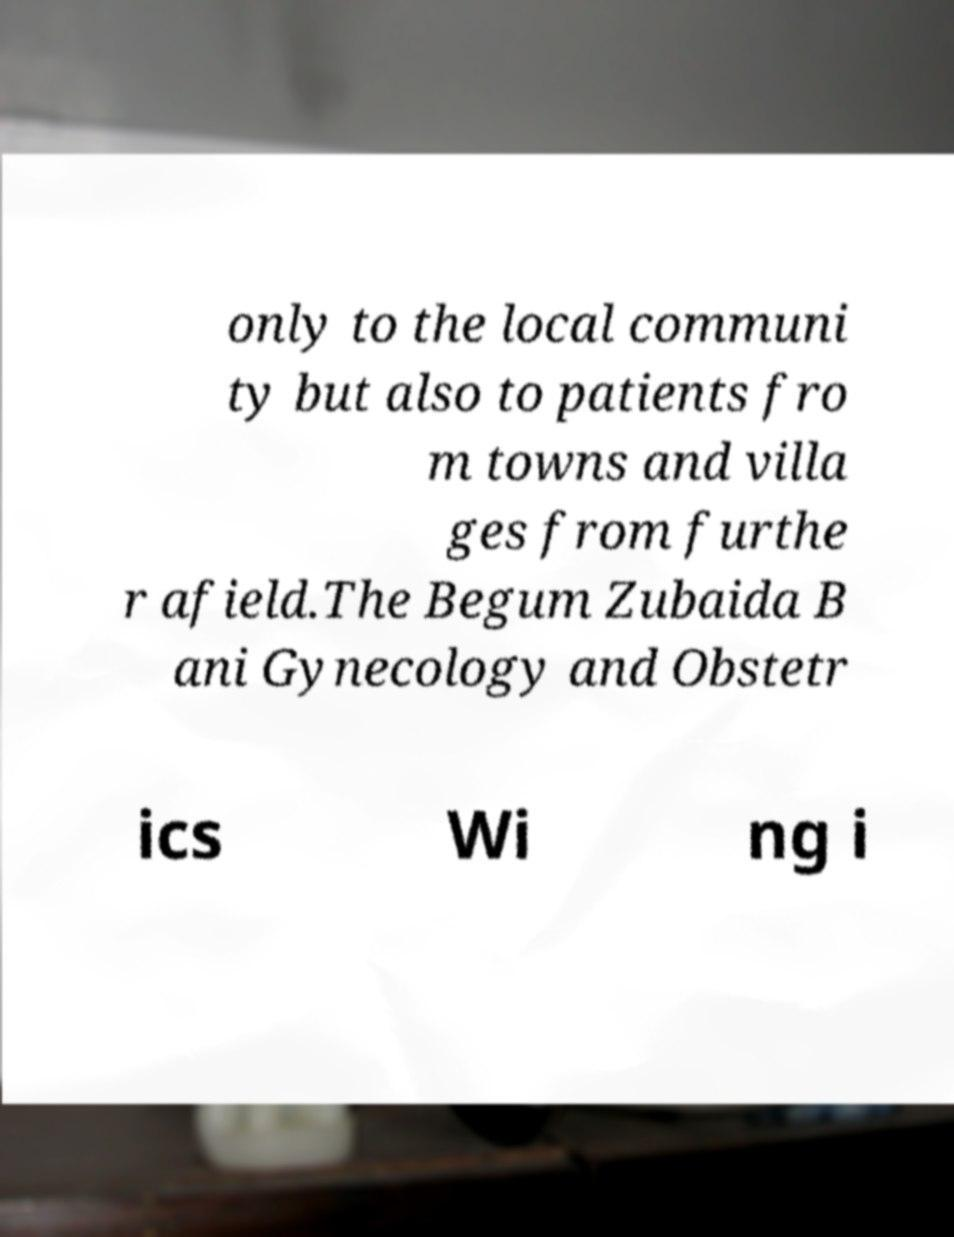Can you accurately transcribe the text from the provided image for me? only to the local communi ty but also to patients fro m towns and villa ges from furthe r afield.The Begum Zubaida B ani Gynecology and Obstetr ics Wi ng i 